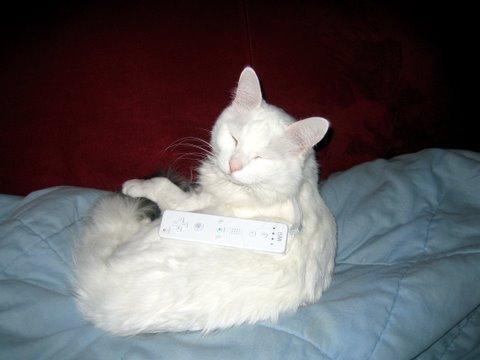How many cat's paw can you see?
Give a very brief answer. 1. How many cats are there?
Give a very brief answer. 1. How many people are wearing a red jacket?
Give a very brief answer. 0. 